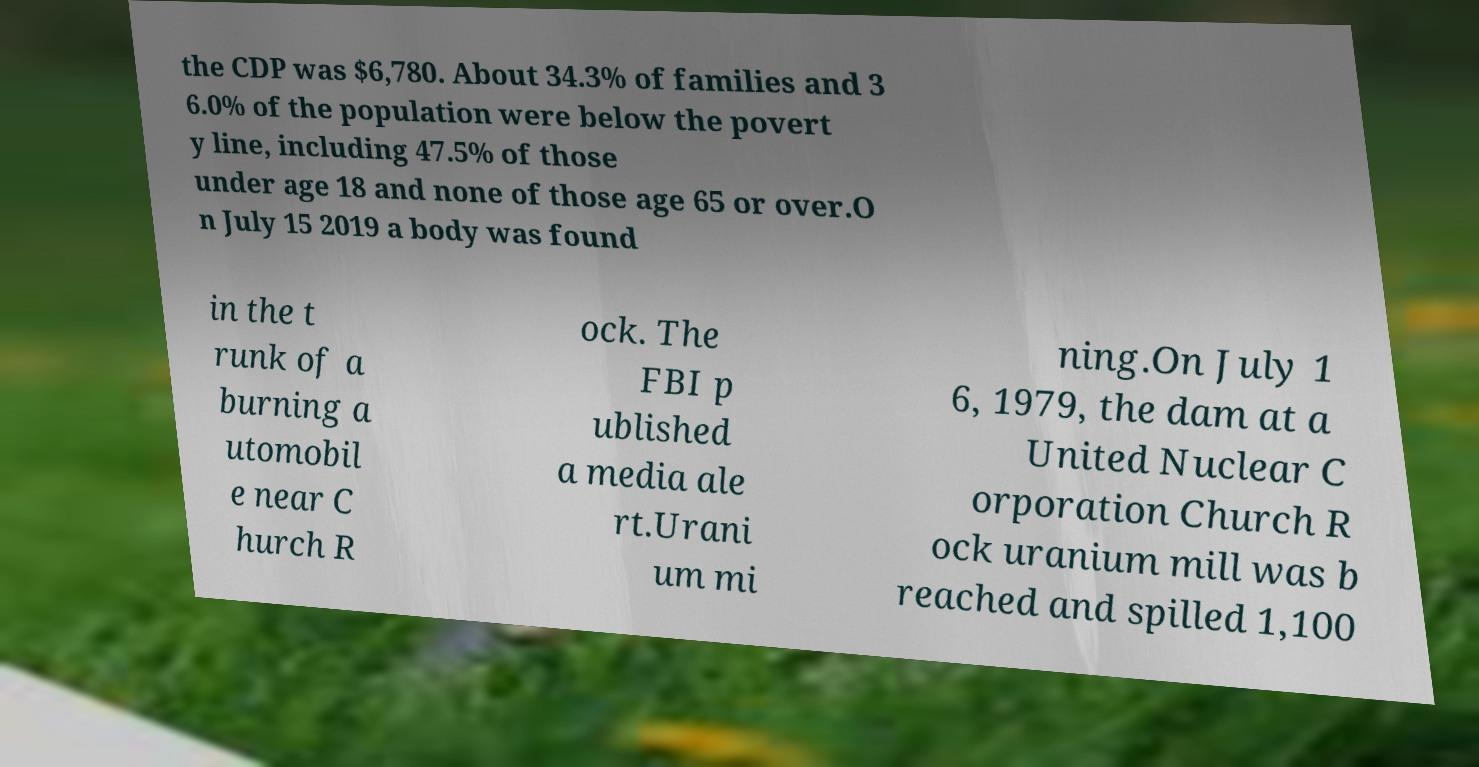For documentation purposes, I need the text within this image transcribed. Could you provide that? the CDP was $6,780. About 34.3% of families and 3 6.0% of the population were below the povert y line, including 47.5% of those under age 18 and none of those age 65 or over.O n July 15 2019 a body was found in the t runk of a burning a utomobil e near C hurch R ock. The FBI p ublished a media ale rt.Urani um mi ning.On July 1 6, 1979, the dam at a United Nuclear C orporation Church R ock uranium mill was b reached and spilled 1,100 